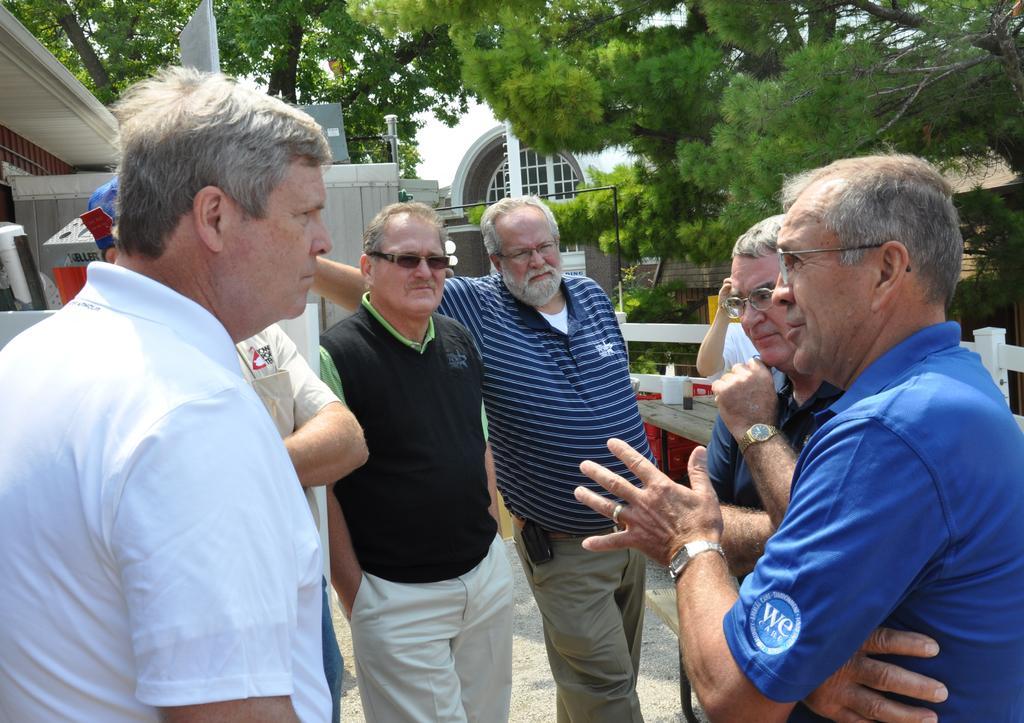How would you summarize this image in a sentence or two? In the image in the center, we can see a few people are standing. In the background, we can see buildings, trees, fences etc. 